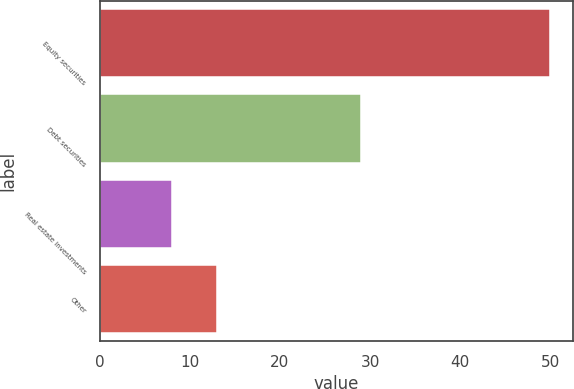<chart> <loc_0><loc_0><loc_500><loc_500><bar_chart><fcel>Equity securities<fcel>Debt securities<fcel>Real estate investments<fcel>Other<nl><fcel>50<fcel>29<fcel>8<fcel>13<nl></chart> 